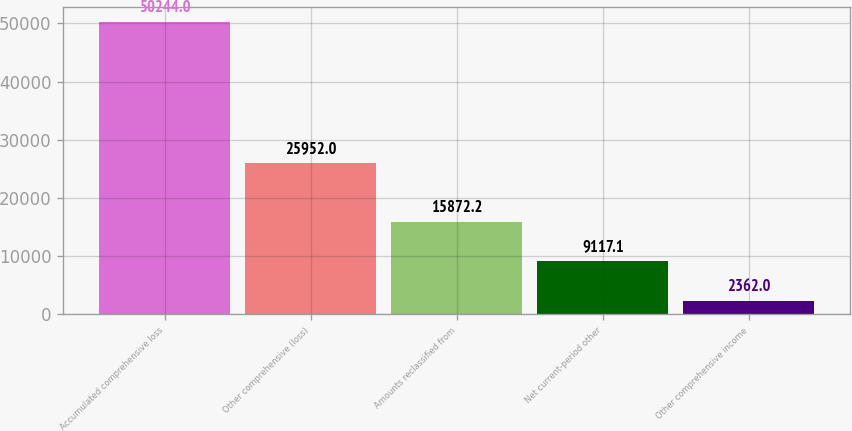Convert chart to OTSL. <chart><loc_0><loc_0><loc_500><loc_500><bar_chart><fcel>Accumulated comprehensive loss<fcel>Other comprehensive (loss)<fcel>Amounts reclassified from<fcel>Net current-period other<fcel>Other comprehensive income<nl><fcel>50244<fcel>25952<fcel>15872.2<fcel>9117.1<fcel>2362<nl></chart> 